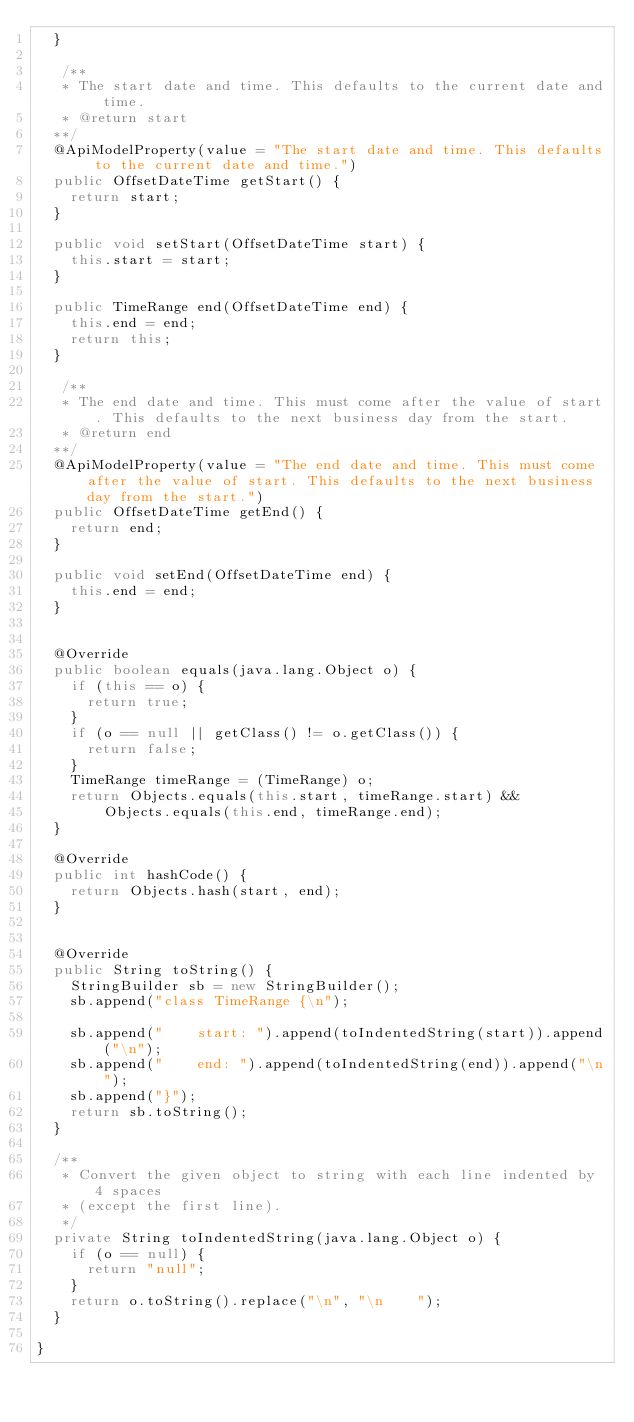Convert code to text. <code><loc_0><loc_0><loc_500><loc_500><_Java_>  }

   /**
   * The start date and time. This defaults to the current date and time.
   * @return start
  **/
  @ApiModelProperty(value = "The start date and time. This defaults to the current date and time.")
  public OffsetDateTime getStart() {
    return start;
  }

  public void setStart(OffsetDateTime start) {
    this.start = start;
  }

  public TimeRange end(OffsetDateTime end) {
    this.end = end;
    return this;
  }

   /**
   * The end date and time. This must come after the value of start. This defaults to the next business day from the start.
   * @return end
  **/
  @ApiModelProperty(value = "The end date and time. This must come after the value of start. This defaults to the next business day from the start.")
  public OffsetDateTime getEnd() {
    return end;
  }

  public void setEnd(OffsetDateTime end) {
    this.end = end;
  }


  @Override
  public boolean equals(java.lang.Object o) {
    if (this == o) {
      return true;
    }
    if (o == null || getClass() != o.getClass()) {
      return false;
    }
    TimeRange timeRange = (TimeRange) o;
    return Objects.equals(this.start, timeRange.start) &&
        Objects.equals(this.end, timeRange.end);
  }

  @Override
  public int hashCode() {
    return Objects.hash(start, end);
  }


  @Override
  public String toString() {
    StringBuilder sb = new StringBuilder();
    sb.append("class TimeRange {\n");
    
    sb.append("    start: ").append(toIndentedString(start)).append("\n");
    sb.append("    end: ").append(toIndentedString(end)).append("\n");
    sb.append("}");
    return sb.toString();
  }

  /**
   * Convert the given object to string with each line indented by 4 spaces
   * (except the first line).
   */
  private String toIndentedString(java.lang.Object o) {
    if (o == null) {
      return "null";
    }
    return o.toString().replace("\n", "\n    ");
  }

}

</code> 